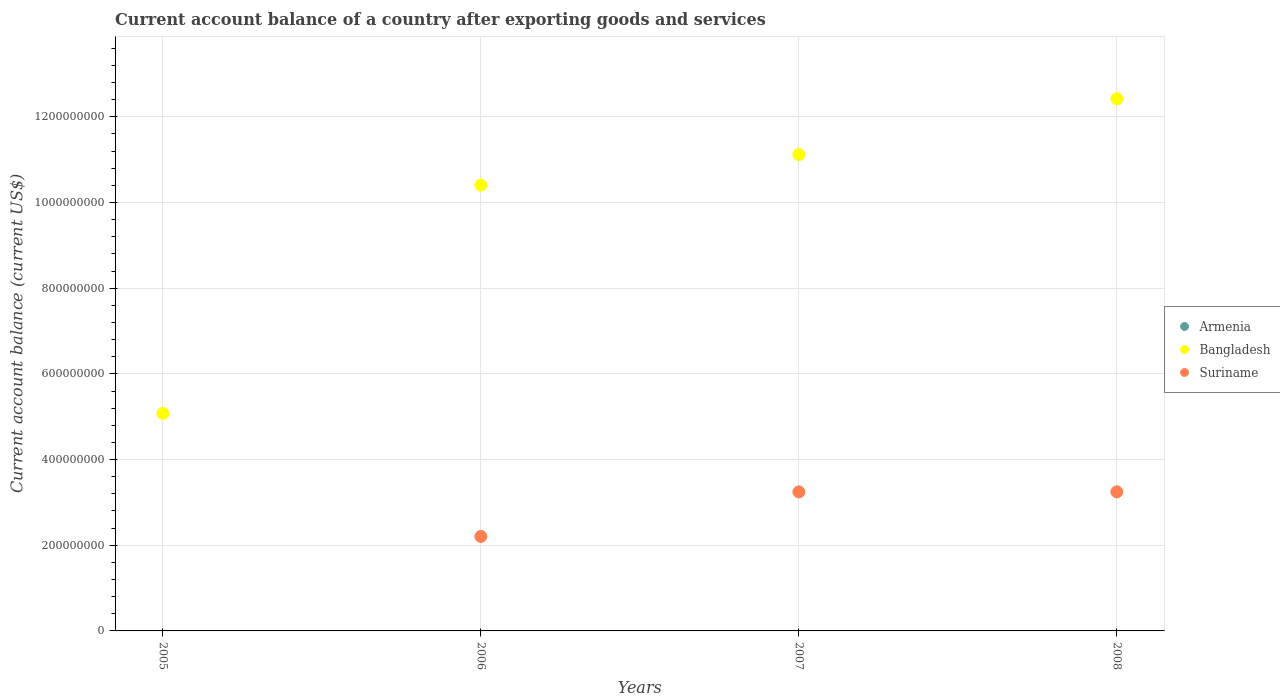Is the number of dotlines equal to the number of legend labels?
Make the answer very short. No. What is the account balance in Suriname in 2006?
Your answer should be compact. 2.21e+08. Across all years, what is the maximum account balance in Suriname?
Make the answer very short. 3.25e+08. Across all years, what is the minimum account balance in Bangladesh?
Ensure brevity in your answer.  5.08e+08. What is the difference between the account balance in Suriname in 2006 and that in 2007?
Offer a very short reply. -1.04e+08. What is the difference between the account balance in Bangladesh in 2007 and the account balance in Suriname in 2008?
Ensure brevity in your answer.  7.87e+08. What is the average account balance in Armenia per year?
Ensure brevity in your answer.  0. In the year 2008, what is the difference between the account balance in Bangladesh and account balance in Suriname?
Your answer should be very brief. 9.18e+08. What is the ratio of the account balance in Bangladesh in 2006 to that in 2007?
Provide a short and direct response. 0.94. Is the account balance in Bangladesh in 2006 less than that in 2008?
Ensure brevity in your answer.  Yes. Is the difference between the account balance in Bangladesh in 2007 and 2008 greater than the difference between the account balance in Suriname in 2007 and 2008?
Keep it short and to the point. No. What is the difference between the highest and the lowest account balance in Bangladesh?
Keep it short and to the point. 7.35e+08. Is the sum of the account balance in Bangladesh in 2006 and 2007 greater than the maximum account balance in Armenia across all years?
Ensure brevity in your answer.  Yes. Is it the case that in every year, the sum of the account balance in Armenia and account balance in Suriname  is greater than the account balance in Bangladesh?
Your answer should be very brief. No. Does the account balance in Suriname monotonically increase over the years?
Provide a succinct answer. Yes. Is the account balance in Bangladesh strictly greater than the account balance in Suriname over the years?
Offer a very short reply. Yes. Is the account balance in Suriname strictly less than the account balance in Bangladesh over the years?
Keep it short and to the point. Yes. Are the values on the major ticks of Y-axis written in scientific E-notation?
Offer a terse response. No. Does the graph contain any zero values?
Your answer should be compact. Yes. Does the graph contain grids?
Your answer should be compact. Yes. How many legend labels are there?
Offer a terse response. 3. How are the legend labels stacked?
Your answer should be very brief. Vertical. What is the title of the graph?
Your answer should be compact. Current account balance of a country after exporting goods and services. Does "Ghana" appear as one of the legend labels in the graph?
Ensure brevity in your answer.  No. What is the label or title of the Y-axis?
Your answer should be very brief. Current account balance (current US$). What is the Current account balance (current US$) of Armenia in 2005?
Your answer should be compact. 0. What is the Current account balance (current US$) of Bangladesh in 2005?
Offer a very short reply. 5.08e+08. What is the Current account balance (current US$) in Suriname in 2005?
Offer a terse response. 0. What is the Current account balance (current US$) in Armenia in 2006?
Provide a short and direct response. 0. What is the Current account balance (current US$) in Bangladesh in 2006?
Keep it short and to the point. 1.04e+09. What is the Current account balance (current US$) in Suriname in 2006?
Provide a succinct answer. 2.21e+08. What is the Current account balance (current US$) in Bangladesh in 2007?
Keep it short and to the point. 1.11e+09. What is the Current account balance (current US$) in Suriname in 2007?
Provide a succinct answer. 3.24e+08. What is the Current account balance (current US$) of Bangladesh in 2008?
Ensure brevity in your answer.  1.24e+09. What is the Current account balance (current US$) of Suriname in 2008?
Ensure brevity in your answer.  3.25e+08. Across all years, what is the maximum Current account balance (current US$) of Bangladesh?
Your response must be concise. 1.24e+09. Across all years, what is the maximum Current account balance (current US$) in Suriname?
Keep it short and to the point. 3.25e+08. Across all years, what is the minimum Current account balance (current US$) in Bangladesh?
Provide a short and direct response. 5.08e+08. Across all years, what is the minimum Current account balance (current US$) of Suriname?
Offer a terse response. 0. What is the total Current account balance (current US$) of Armenia in the graph?
Your answer should be compact. 0. What is the total Current account balance (current US$) in Bangladesh in the graph?
Keep it short and to the point. 3.90e+09. What is the total Current account balance (current US$) in Suriname in the graph?
Your response must be concise. 8.70e+08. What is the difference between the Current account balance (current US$) in Bangladesh in 2005 and that in 2006?
Give a very brief answer. -5.33e+08. What is the difference between the Current account balance (current US$) of Bangladesh in 2005 and that in 2007?
Your response must be concise. -6.04e+08. What is the difference between the Current account balance (current US$) in Bangladesh in 2005 and that in 2008?
Offer a terse response. -7.35e+08. What is the difference between the Current account balance (current US$) in Bangladesh in 2006 and that in 2007?
Your answer should be compact. -7.13e+07. What is the difference between the Current account balance (current US$) in Suriname in 2006 and that in 2007?
Your response must be concise. -1.04e+08. What is the difference between the Current account balance (current US$) of Bangladesh in 2006 and that in 2008?
Your answer should be very brief. -2.02e+08. What is the difference between the Current account balance (current US$) of Suriname in 2006 and that in 2008?
Offer a terse response. -1.04e+08. What is the difference between the Current account balance (current US$) of Bangladesh in 2007 and that in 2008?
Offer a terse response. -1.30e+08. What is the difference between the Current account balance (current US$) in Suriname in 2007 and that in 2008?
Provide a short and direct response. -2.00e+05. What is the difference between the Current account balance (current US$) of Bangladesh in 2005 and the Current account balance (current US$) of Suriname in 2006?
Offer a terse response. 2.87e+08. What is the difference between the Current account balance (current US$) in Bangladesh in 2005 and the Current account balance (current US$) in Suriname in 2007?
Ensure brevity in your answer.  1.83e+08. What is the difference between the Current account balance (current US$) in Bangladesh in 2005 and the Current account balance (current US$) in Suriname in 2008?
Provide a short and direct response. 1.83e+08. What is the difference between the Current account balance (current US$) of Bangladesh in 2006 and the Current account balance (current US$) of Suriname in 2007?
Your answer should be compact. 7.16e+08. What is the difference between the Current account balance (current US$) in Bangladesh in 2006 and the Current account balance (current US$) in Suriname in 2008?
Ensure brevity in your answer.  7.16e+08. What is the difference between the Current account balance (current US$) of Bangladesh in 2007 and the Current account balance (current US$) of Suriname in 2008?
Provide a succinct answer. 7.87e+08. What is the average Current account balance (current US$) of Armenia per year?
Ensure brevity in your answer.  0. What is the average Current account balance (current US$) in Bangladesh per year?
Keep it short and to the point. 9.76e+08. What is the average Current account balance (current US$) of Suriname per year?
Ensure brevity in your answer.  2.17e+08. In the year 2006, what is the difference between the Current account balance (current US$) in Bangladesh and Current account balance (current US$) in Suriname?
Your answer should be compact. 8.20e+08. In the year 2007, what is the difference between the Current account balance (current US$) in Bangladesh and Current account balance (current US$) in Suriname?
Provide a short and direct response. 7.87e+08. In the year 2008, what is the difference between the Current account balance (current US$) of Bangladesh and Current account balance (current US$) of Suriname?
Ensure brevity in your answer.  9.18e+08. What is the ratio of the Current account balance (current US$) of Bangladesh in 2005 to that in 2006?
Your response must be concise. 0.49. What is the ratio of the Current account balance (current US$) in Bangladesh in 2005 to that in 2007?
Make the answer very short. 0.46. What is the ratio of the Current account balance (current US$) in Bangladesh in 2005 to that in 2008?
Ensure brevity in your answer.  0.41. What is the ratio of the Current account balance (current US$) of Bangladesh in 2006 to that in 2007?
Your answer should be very brief. 0.94. What is the ratio of the Current account balance (current US$) of Suriname in 2006 to that in 2007?
Your answer should be very brief. 0.68. What is the ratio of the Current account balance (current US$) in Bangladesh in 2006 to that in 2008?
Offer a very short reply. 0.84. What is the ratio of the Current account balance (current US$) in Suriname in 2006 to that in 2008?
Ensure brevity in your answer.  0.68. What is the ratio of the Current account balance (current US$) in Bangladesh in 2007 to that in 2008?
Keep it short and to the point. 0.9. What is the difference between the highest and the second highest Current account balance (current US$) in Bangladesh?
Your response must be concise. 1.30e+08. What is the difference between the highest and the lowest Current account balance (current US$) of Bangladesh?
Provide a short and direct response. 7.35e+08. What is the difference between the highest and the lowest Current account balance (current US$) of Suriname?
Make the answer very short. 3.25e+08. 